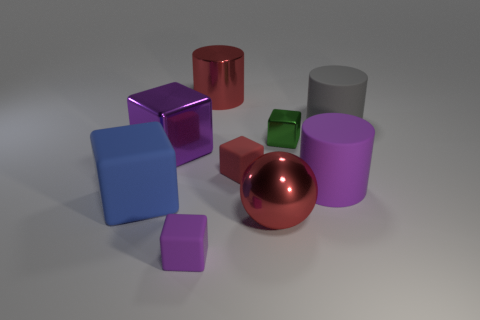Add 1 matte cylinders. How many objects exist? 10 Subtract all large matte cylinders. How many cylinders are left? 1 Subtract all blue blocks. How many blocks are left? 4 Subtract all yellow blocks. Subtract all green balls. How many blocks are left? 5 Subtract all cylinders. How many objects are left? 6 Add 7 large purple metallic balls. How many large purple metallic balls exist? 7 Subtract 0 gray blocks. How many objects are left? 9 Subtract all purple rubber objects. Subtract all large purple metallic cubes. How many objects are left? 6 Add 6 large gray cylinders. How many large gray cylinders are left? 7 